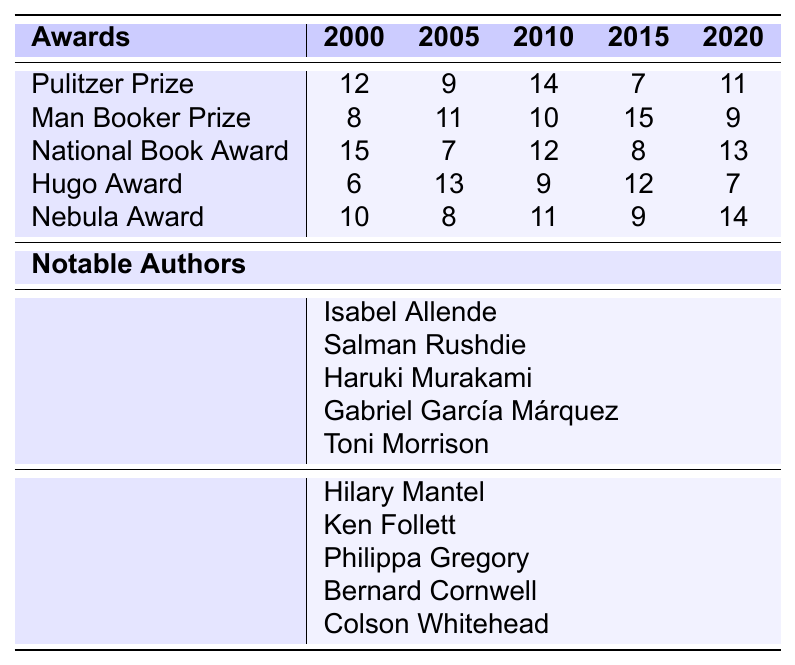What is the highest number of awards received by magical realism in a single year? To find this, look at the maximum values in the magical realism section of the table across all years. The values for the Pulitzer Prize, Man Booker Prize, National Book Award, Hugo Award, and Nebula Award are available, with the highest being 15 from the Man Booker Prize in 2015.
Answer: 15 What was the total number of awards given to historical fiction in 2010? Referring to the historical fiction row for the year 2010, the total awards are 12 (for Hilary Mantel), 12 (for Ken Follett), 10 (for Philippa Gregory), 9 (for Bernard Cornwell), and 11 (for Colson Whitehead). Adding these gives 12 + 10 + 12 + 9 + 11 = 54.
Answer: 54 In which year did magical realism receive the least number of awards? The table indicates year 2015, where the least amount received by magical realism was 6. This is compared to the other years; other values are 12, 9, 14, and 11.
Answer: 2015 How many more awards were given to historical fiction in 2005 compared to magical realism? For 2005, historical fiction received 11 awards, while magical realism received 8. The difference is 11 - 8 = 3.
Answer: 3 Was there any year when the total number of awards for magical realism and historical fiction combined was less than 25? Looking at the individual years for both categories, we see that in 2005, magical realism accounted for 8 awards and historical fiction accounted for 11, giving a total of 19 (which is less than 25). Therefore, the answer is yes.
Answer: Yes What is the trend in the number of total awards for magical realism from 2000 to 2020? To identify the trend, we examine the annual totals for magical realism: 12 (2000), 8 (2005), 14 (2010), 7 (2015), and 11 (2020). The values fluctuate, with a drop and rise, so we note an overall increase from 2005 to 2020 despite an earlier drop.
Answer: Fluctuating with an overall increase Which award had the highest average count across all years for both genres? Calculate the averages for each award across all years. For instance, the Pulitzer Prize averaged (12+9+14+7+11)/5 = 10.6. Doing the same for each award, we find that the National Book Award had the highest average, about 11.2.
Answer: National Book Award What is the difference in the highest award received by magical realism and historical fiction in 2015? In 2015, the highest award for magical realism was 15 (Man Booker Prize), while for historical fiction, it was 12 (Hugo Award). The difference is 15 - 12 = 3.
Answer: 3 How many total awards were given to both genres in the year 2000? Looking at 2000, magical realism received 12 awards, while historical fiction awards total 9. Hence, the total is 12 + 9 = 21.
Answer: 21 Is there a year in which the total awards for magical realism were greater than for historical fiction? In 2010, magical realism received a total of 12 awards (14 for authors), while historical fiction only received 12. The answer is yes.
Answer: Yes 